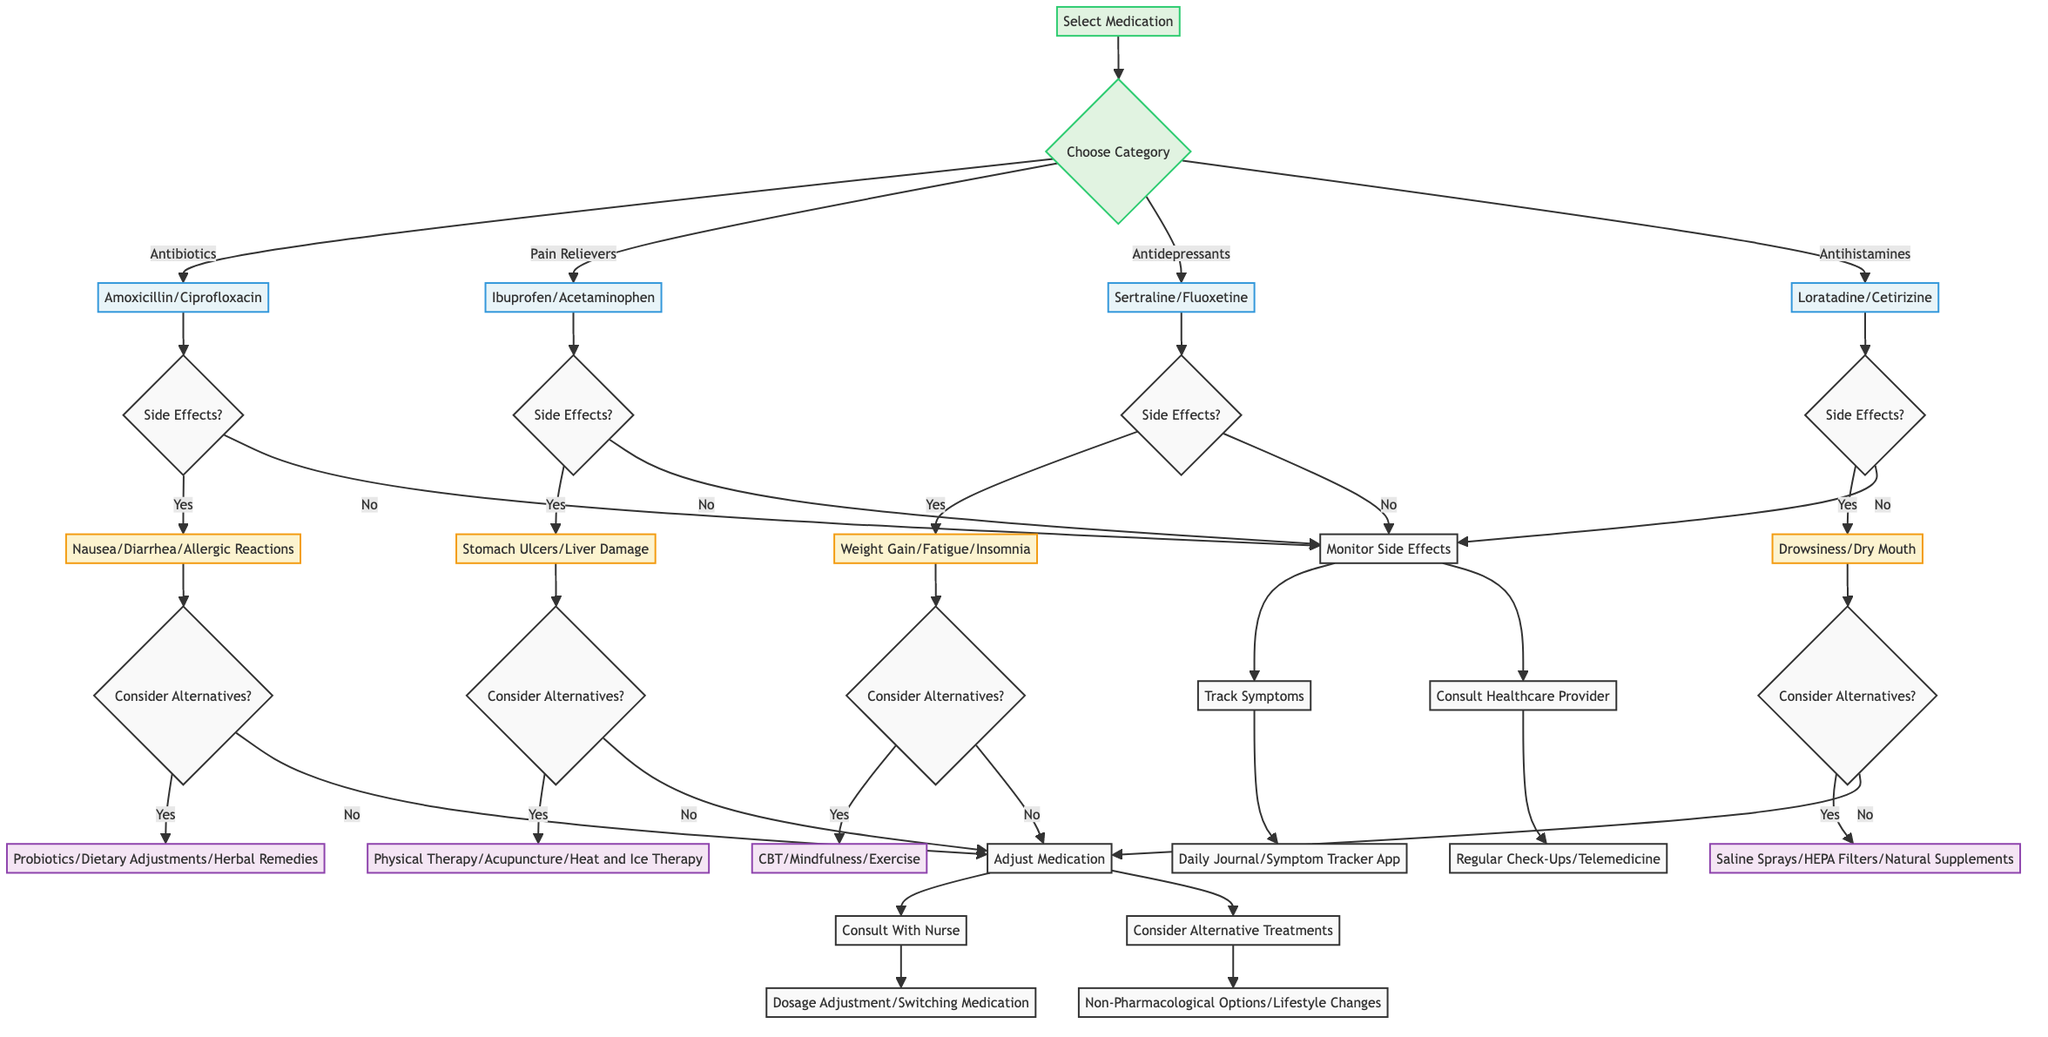What are the common medications listed under Antibiotics? The diagram shows that the common medications listed under the Antibiotics category are Amoxicillin and Ciprofloxacin. These medications are the first two nodes under the Antibiotics category.
Answer: Amoxicillin, Ciprofloxacin What side effects are associated with Pain Relievers? The diagram indicates that the side effects of Pain Relievers include Stomach Ulcers and Liver Damage. These are shown as the two outcomes from the Pain Relievers option in the diagram.
Answer: Stomach Ulcers, Liver Damage How many categories of medication are shown in the diagram? The diagram displays four categories of medication: Antibiotics, Pain Relievers, Antidepressants, and Antihistamines. This can be counted directly from the decision node labeled 'Choose Category.'
Answer: 4 If a patient reports allergic reactions after taking Antibiotics, what should they consider next? According to the diagram, if a patient experiences allergic reactions as a side effect of Antibiotics, they should consider alternative treatments, such as Probiotics, Dietary Adjustments, and Herbal Remedies. This follows the Yes path from the side effects question for Antibiotics.
Answer: Probiotics, Dietary Adjustments, Herbal Remedies What options should be monitored if no side effects occur? The diagram specifies two monitoring options: Track Symptoms and Consult Healthcare Provider. Both are branches from the "Monitor Side Effects" node after confirming that there were no side effects.
Answer: Track Symptoms, Consult Healthcare Provider What alternatives can a patient consider if they experience weight gain from Antidepressants? Given the diagram, a patient experiencing weight gain as a side effect of Antidepressants may consider alternatives including Cognitive Behavioral Therapy, Mindfulness Meditation, or Exercise. This is derived from the side effects question for Antidepressants.
Answer: Cognitive Behavioral Therapy, Mindfulness Meditation, Exercise How can a patient adjust their medication if side effects occur? The diagram states that if side effects occur, a patient can adjust their medication by consulting with a nurse for Dosage Adjustment or Switching Medication, or they can consider Alternative Treatments like Non-Pharmacological Options or Lifestyle Changes. These options are presented under the Adjust Medication node.
Answer: Consult With Nurse, Consider Alternative Treatments Which antihistamine medications are commonly mentioned in the diagram? The common antihistamine medications listed in the diagram are Loratadine and Cetirizine. These medications are specified directly under the Antihistamines decision path.
Answer: Loratadine, Cetirizine What symptom tracking options are available for patients? The diagram identifies two symptom tracking options: Daily Journal and Symptom Tracker App. These details are provided under the Tracking Symptoms node.
Answer: Daily Journal, Symptom Tracker App 